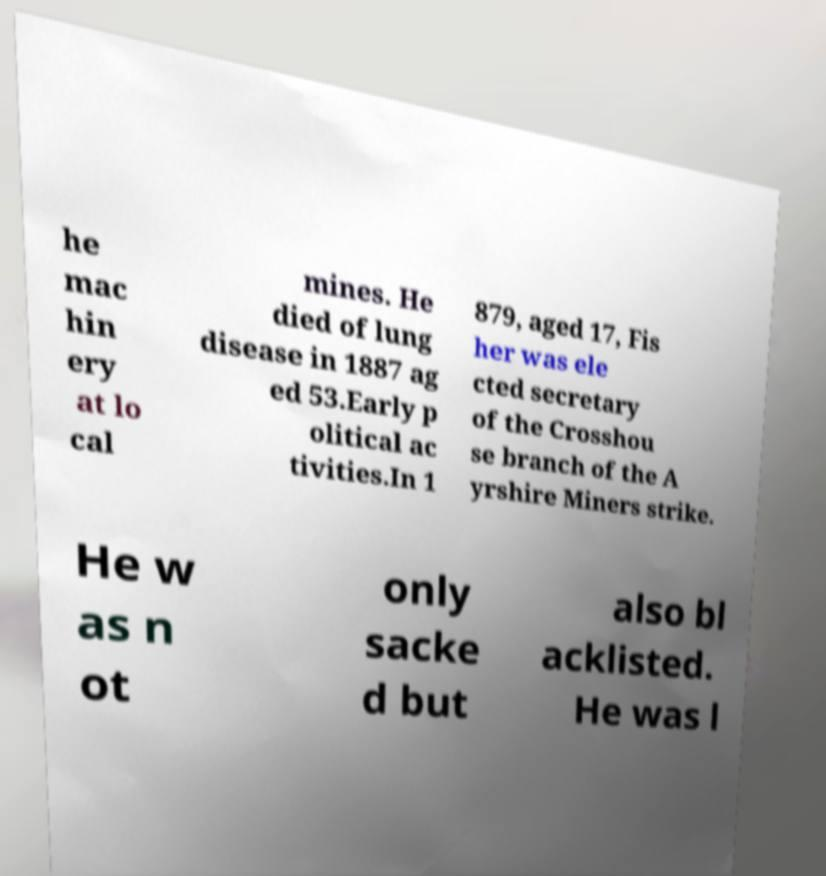There's text embedded in this image that I need extracted. Can you transcribe it verbatim? he mac hin ery at lo cal mines. He died of lung disease in 1887 ag ed 53.Early p olitical ac tivities.In 1 879, aged 17, Fis her was ele cted secretary of the Crosshou se branch of the A yrshire Miners strike. He w as n ot only sacke d but also bl acklisted. He was l 